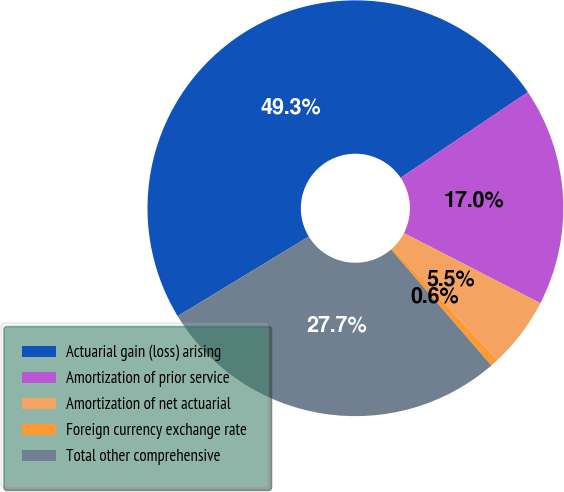Convert chart. <chart><loc_0><loc_0><loc_500><loc_500><pie_chart><fcel>Actuarial gain (loss) arising<fcel>Amortization of prior service<fcel>Amortization of net actuarial<fcel>Foreign currency exchange rate<fcel>Total other comprehensive<nl><fcel>49.26%<fcel>16.97%<fcel>5.49%<fcel>0.62%<fcel>27.66%<nl></chart> 